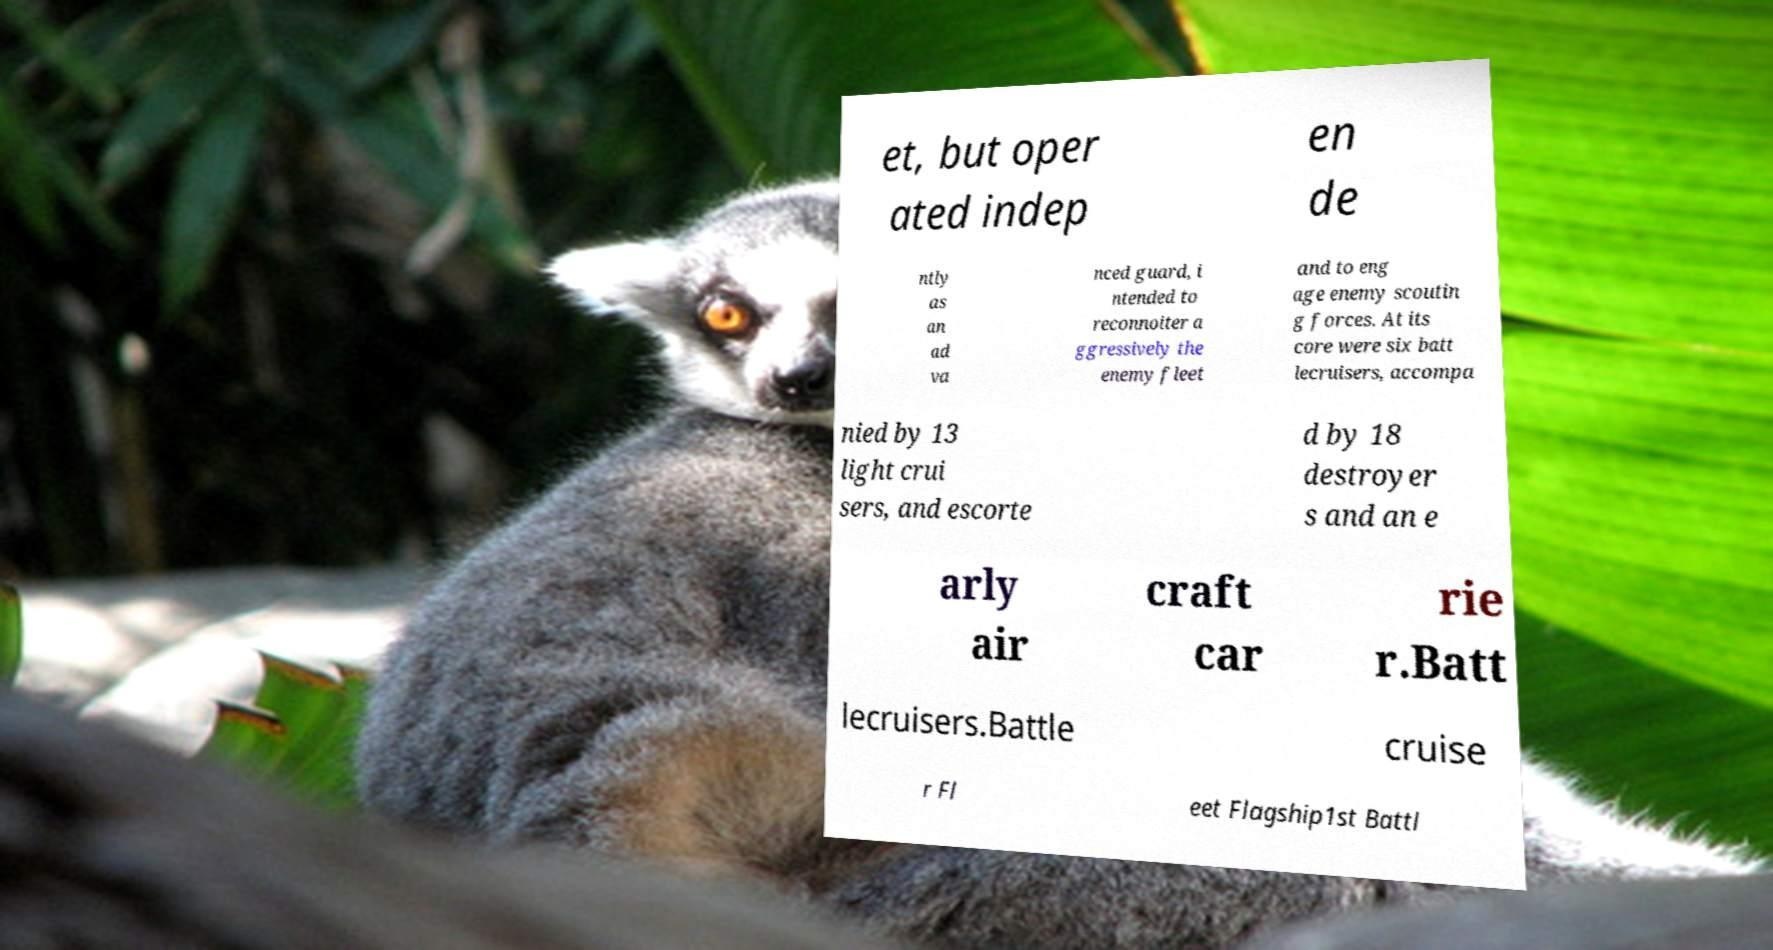Could you extract and type out the text from this image? et, but oper ated indep en de ntly as an ad va nced guard, i ntended to reconnoiter a ggressively the enemy fleet and to eng age enemy scoutin g forces. At its core were six batt lecruisers, accompa nied by 13 light crui sers, and escorte d by 18 destroyer s and an e arly air craft car rie r.Batt lecruisers.Battle cruise r Fl eet Flagship1st Battl 